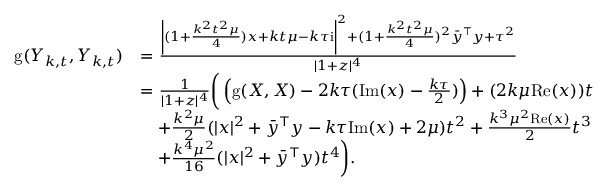Convert formula to latex. <formula><loc_0><loc_0><loc_500><loc_500>\begin{array} { r l } { g ( Y _ { k , t } , Y _ { k , t } ) } & { = \frac { \left | ( 1 + \frac { k ^ { 2 } t ^ { 2 } \mu } { 4 } ) x + k t \mu - k \tau i \right | ^ { 2 } + ( 1 + \frac { k ^ { 2 } t ^ { 2 } \mu } { 4 } ) ^ { 2 } \bar { y } ^ { \top } y + \tau ^ { 2 } } { | 1 + z | ^ { 4 } } } \\ & { = \frac { 1 } { | 1 + z | ^ { 4 } } \left ( \left ( g ( X , X ) - 2 k \tau ( I m ( x ) - \frac { k \tau } { 2 } ) \right ) + ( 2 k \mu R e ( x ) ) t } \\ & { \quad + \frac { k ^ { 2 } \mu } { 2 } ( | x | ^ { 2 } + \bar { y } ^ { \top } y - k \tau I m ( x ) + 2 \mu ) t ^ { 2 } + \frac { k ^ { 3 } \mu ^ { 2 } R e ( x ) } { 2 } t ^ { 3 } } \\ & { \quad + \frac { k ^ { 4 } \mu ^ { 2 } } { 1 6 } ( | x | ^ { 2 } + \bar { y } ^ { \top } y ) t ^ { 4 } \right ) . } \end{array}</formula> 